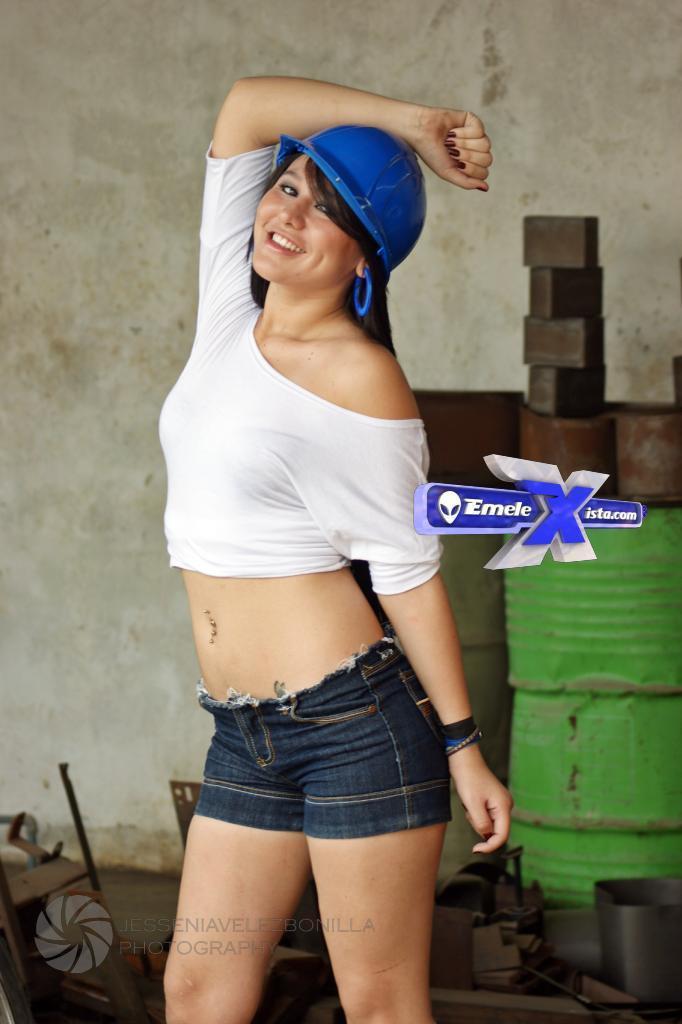Describe this image in one or two sentences. In the front of the image I can see woman is smiling. In the background of the image there is a wall and objects. Watermarks are on the image. 